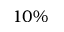<formula> <loc_0><loc_0><loc_500><loc_500>1 0 \%</formula> 